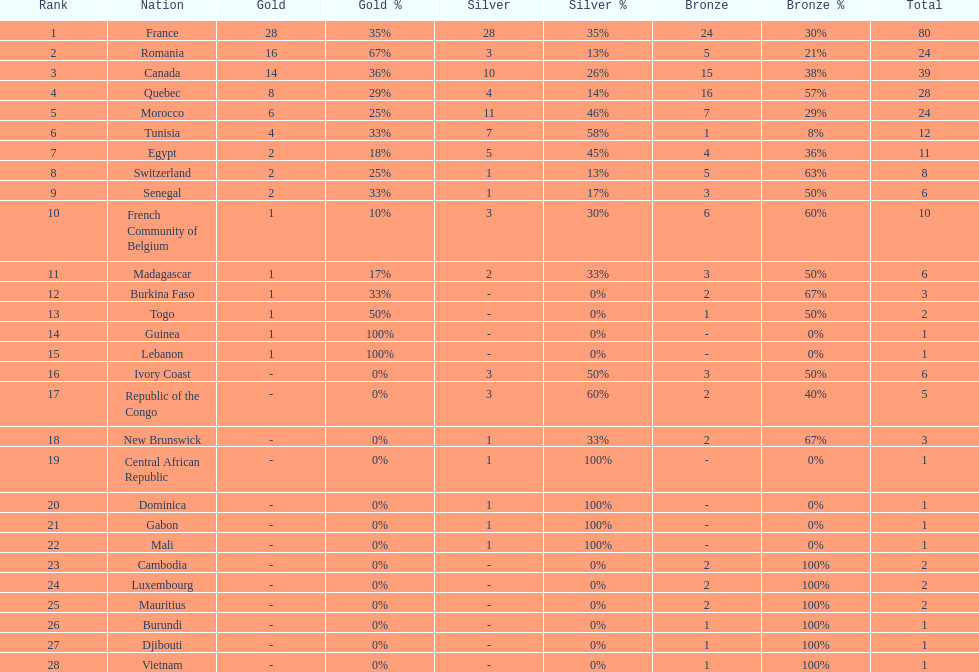I'm looking to parse the entire table for insights. Could you assist me with that? {'header': ['Rank', 'Nation', 'Gold', 'Gold %', 'Silver', 'Silver %', 'Bronze', 'Bronze %', 'Total'], 'rows': [['1', 'France', '28', '35%', '28', '35%', '24', '30%', '80'], ['2', 'Romania', '16', '67%', '3', '13%', '5', '21%', '24'], ['3', 'Canada', '14', '36%', '10', '26%', '15', '38%', '39'], ['4', 'Quebec', '8', '29%', '4', '14%', '16', '57%', '28'], ['5', 'Morocco', '6', '25%', '11', '46%', '7', '29%', '24'], ['6', 'Tunisia', '4', '33%', '7', '58%', '1', '8%', '12'], ['7', 'Egypt', '2', '18%', '5', '45%', '4', '36%', '11'], ['8', 'Switzerland', '2', '25%', '1', '13%', '5', '63%', '8'], ['9', 'Senegal', '2', '33%', '1', '17%', '3', '50%', '6'], ['10', 'French Community of Belgium', '1', '10%', '3', '30%', '6', '60%', '10'], ['11', 'Madagascar', '1', '17%', '2', '33%', '3', '50%', '6'], ['12', 'Burkina Faso', '1', '33%', '-', '0%', '2', '67%', '3'], ['13', 'Togo', '1', '50%', '-', '0%', '1', '50%', '2'], ['14', 'Guinea', '1', '100%', '-', '0%', '-', '0%', '1'], ['15', 'Lebanon', '1', '100%', '-', '0%', '-', '0%', '1'], ['16', 'Ivory Coast', '-', '0%', '3', '50%', '3', '50%', '6'], ['17', 'Republic of the Congo', '-', '0%', '3', '60%', '2', '40%', '5'], ['18', 'New Brunswick', '-', '0%', '1', '33%', '2', '67%', '3'], ['19', 'Central African Republic', '-', '0%', '1', '100%', '-', '0%', '1'], ['20', 'Dominica', '-', '0%', '1', '100%', '-', '0%', '1'], ['21', 'Gabon', '-', '0%', '1', '100%', '-', '0%', '1'], ['22', 'Mali', '-', '0%', '1', '100%', '-', '0%', '1'], ['23', 'Cambodia', '-', '0%', '-', '0%', '2', '100%', '2'], ['24', 'Luxembourg', '-', '0%', '-', '0%', '2', '100%', '2'], ['25', 'Mauritius', '-', '0%', '-', '0%', '2', '100%', '2'], ['26', 'Burundi', '-', '0%', '-', '0%', '1', '100%', '1'], ['27', 'Djibouti', '-', '0%', '-', '0%', '1', '100%', '1'], ['28', 'Vietnam', '-', '0%', '-', '0%', '1', '100%', '1']]} How many more medals did egypt win than ivory coast? 5. 